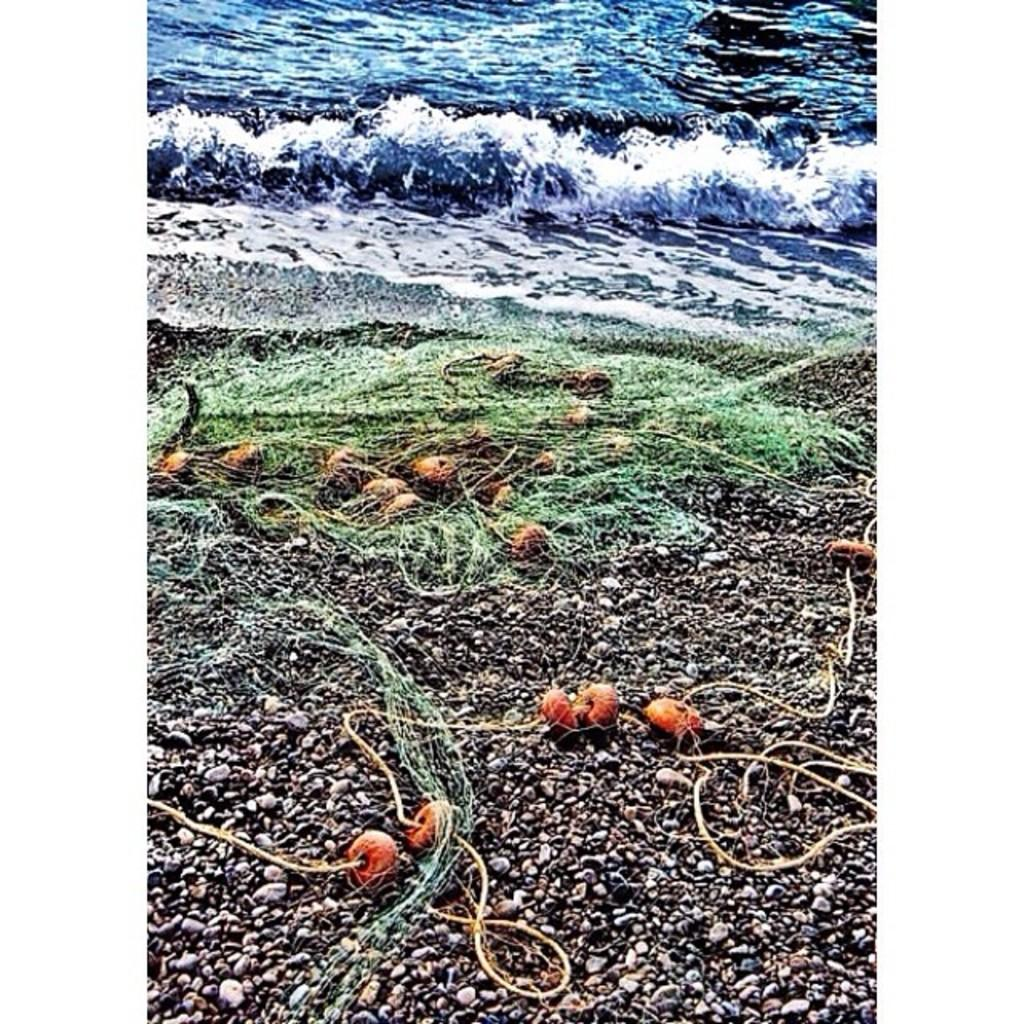What type of landscape is visible at the top of the image? There is a sea at the top of the image. What can be seen in the middle of the image? There are objects in the middle of the image. What is located at the bottom of the image? There is a ground at the bottom of the image. Where is the library located in the image? There is no library present in the image. What type of wool is used to create the objects in the middle of the image? There is no wool or wool-related objects present in the image. 